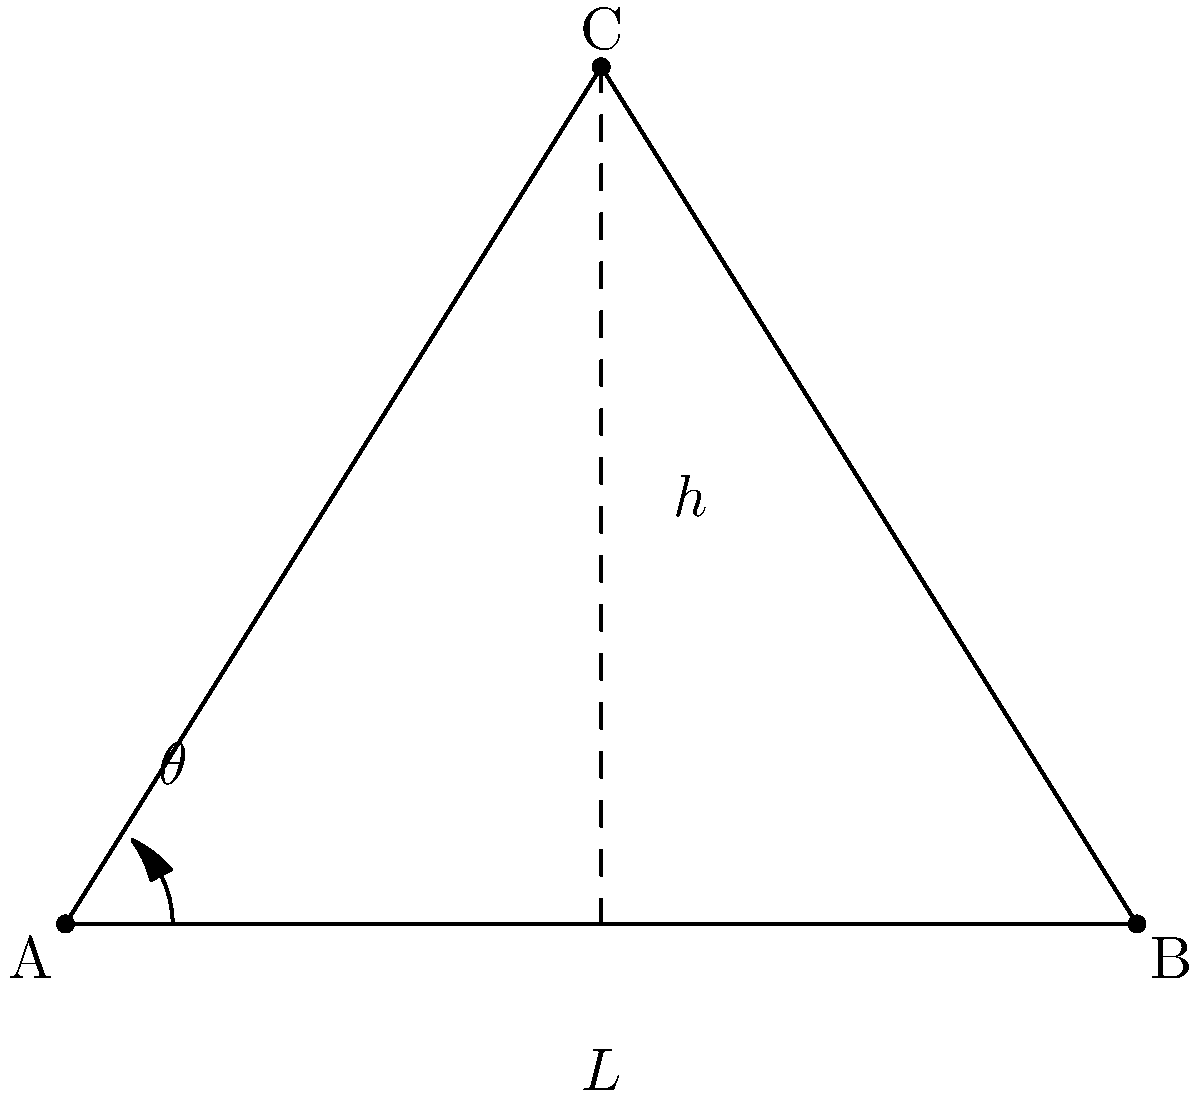In a gymnastic leap, the trajectory of the center of mass can be approximated by a triangle. If the total horizontal distance of the leap is $L$ and the maximum height reached is $h$, what is the optimal take-off angle $\theta$ that maximizes the height $h$ for a given leap distance $L$? Let's approach this step-by-step:

1) In the triangle ABC, AB represents the horizontal distance L, and the height of the triangle represents h.

2) We can express h in terms of L and θ using trigonometry:

   $h = \frac{L}{2} \tan(\theta)$

3) To find the maximum value of h, we need to differentiate h with respect to θ and set it to zero:

   $\frac{dh}{d\theta} = \frac{L}{2} \sec^2(\theta)$

4) Setting this equal to zero:

   $\frac{L}{2} \sec^2(\theta) = 0$

5) However, $\sec^2(\theta)$ is always positive for real θ, and L is a positive constant. Therefore, this equation has no solution, which means there's no local maximum or minimum.

6) This suggests that the maximum occurs at the boundary of the possible range for θ.

7) The maximum possible value for θ is 90°, but this would result in no horizontal distance. The next best option is 45°.

8) We can confirm this by checking values:
   For θ < 45°, tan(θ) < 1
   For θ > 45°, tan(θ) > 1
   At θ = 45°, tan(θ) = 1

9) Therefore, the height h is maximized when θ = 45°.
Answer: 45° 